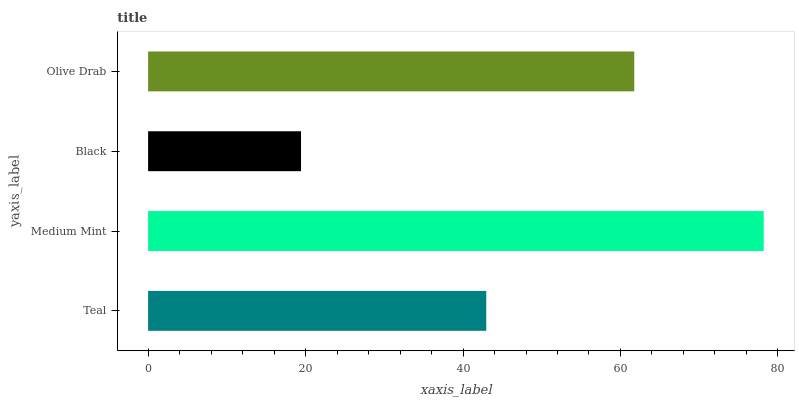Is Black the minimum?
Answer yes or no. Yes. Is Medium Mint the maximum?
Answer yes or no. Yes. Is Medium Mint the minimum?
Answer yes or no. No. Is Black the maximum?
Answer yes or no. No. Is Medium Mint greater than Black?
Answer yes or no. Yes. Is Black less than Medium Mint?
Answer yes or no. Yes. Is Black greater than Medium Mint?
Answer yes or no. No. Is Medium Mint less than Black?
Answer yes or no. No. Is Olive Drab the high median?
Answer yes or no. Yes. Is Teal the low median?
Answer yes or no. Yes. Is Teal the high median?
Answer yes or no. No. Is Olive Drab the low median?
Answer yes or no. No. 